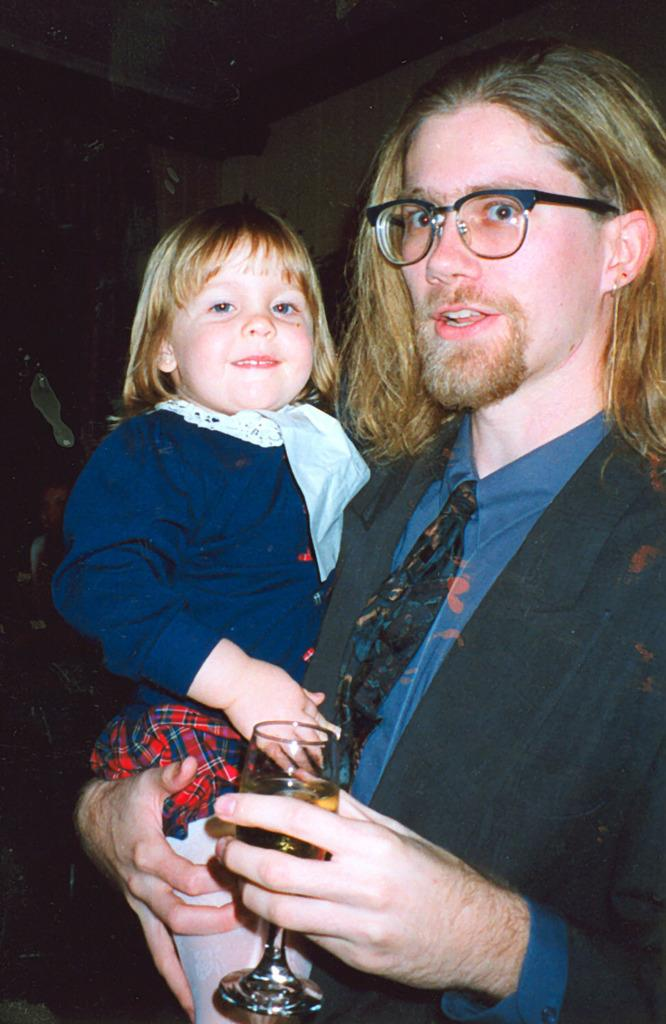What is the man holding in the image? The man is holding a baby and a glass in the image. What is the man wearing in the image? The man is wearing a blue suit and tie, and he is also wearing a spectacle. What can be seen in the background of the image? There is a wall in the background of the image. What type of clouds can be seen in the image? There are no clouds visible in the image; it features a man holding a baby and a glass, wearing a blue suit and tie, and standing in front of a wall. 